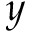Convert formula to latex. <formula><loc_0><loc_0><loc_500><loc_500>y</formula> 